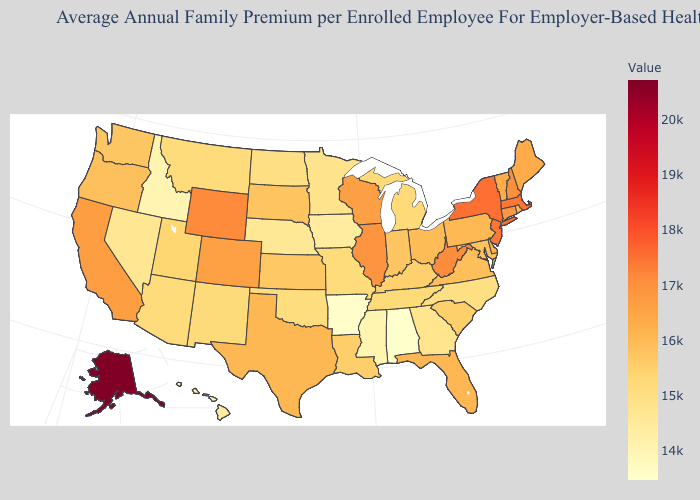Does Alabama have the lowest value in the USA?
Concise answer only. Yes. Does Idaho have the lowest value in the West?
Concise answer only. Yes. Does Alaska have the highest value in the USA?
Concise answer only. Yes. Is the legend a continuous bar?
Give a very brief answer. Yes. Which states have the lowest value in the South?
Short answer required. Alabama. Does Arizona have the highest value in the West?
Quick response, please. No. Is the legend a continuous bar?
Give a very brief answer. Yes. 